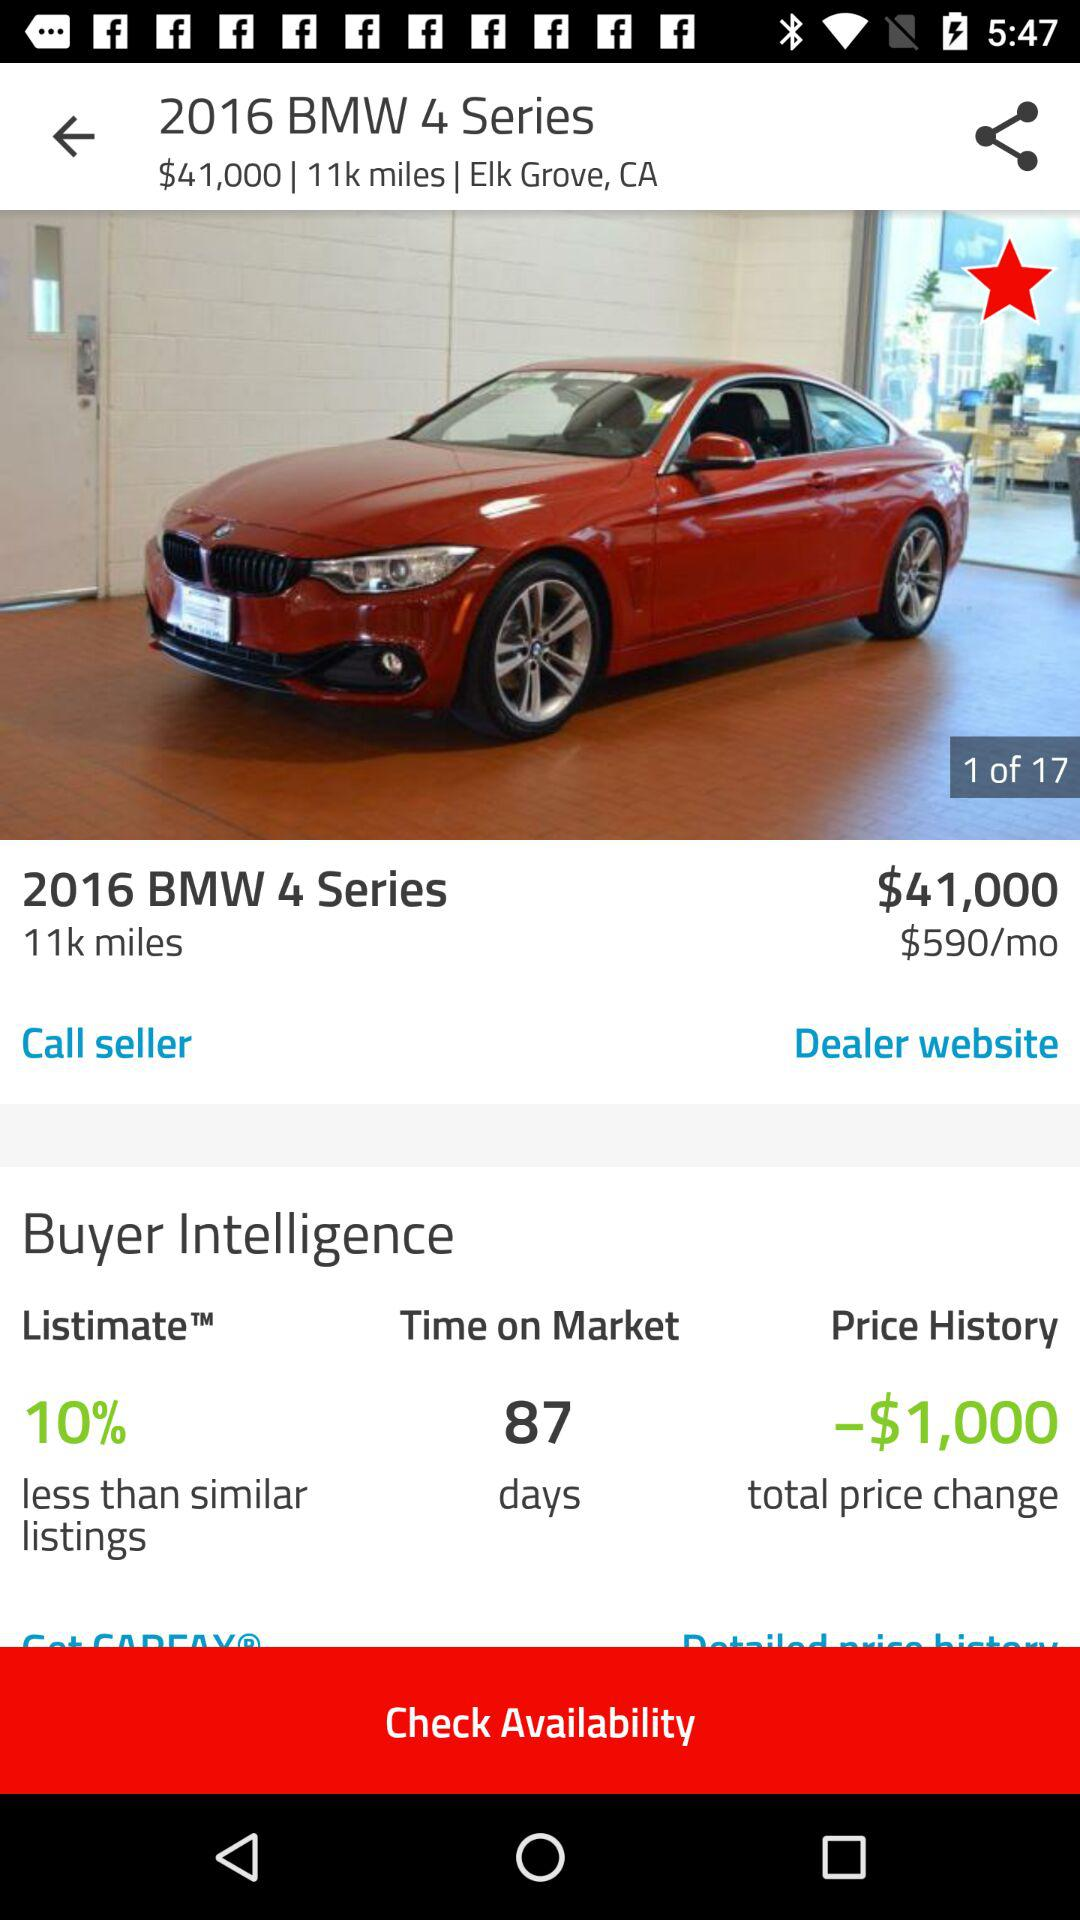What photo is being shown? The shown photo is "2016 BMW 4 Series". 